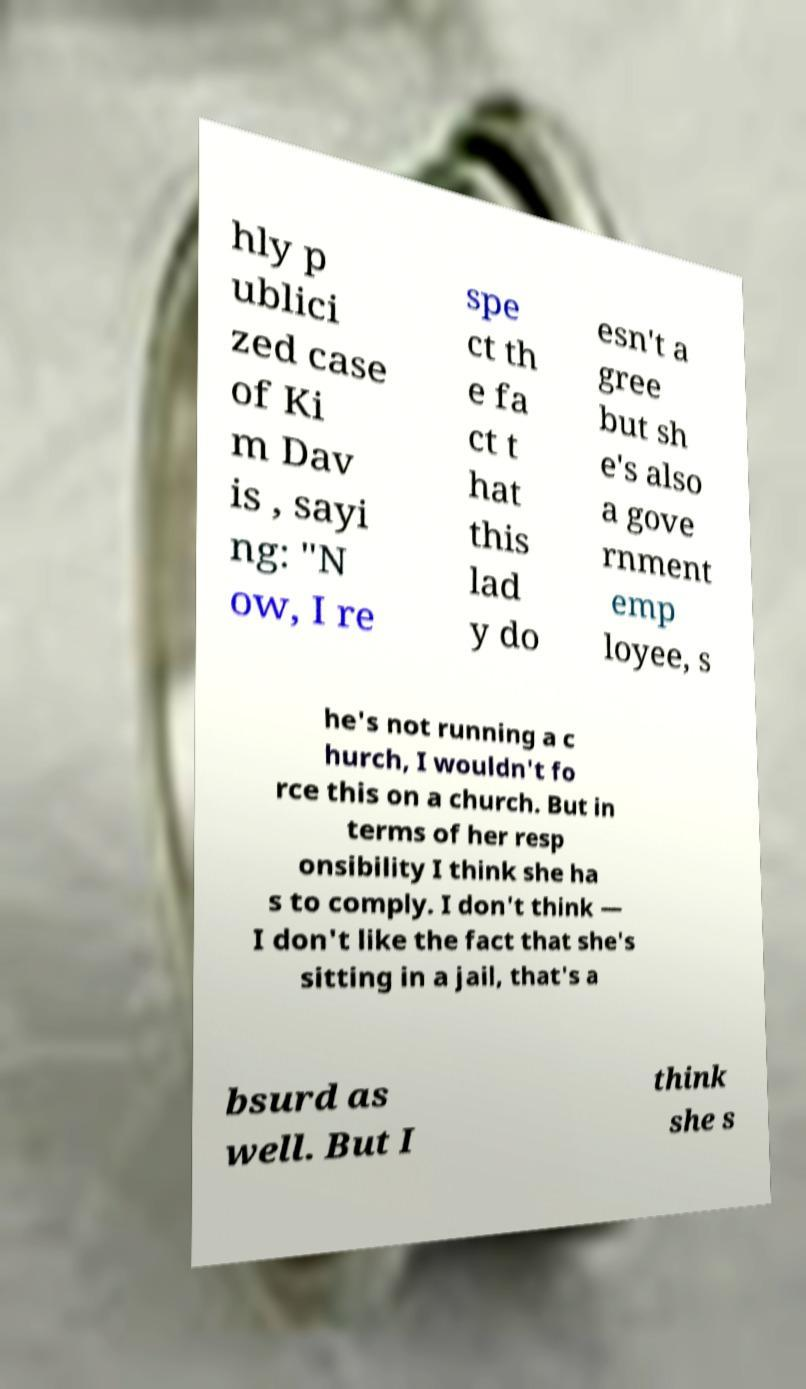Please read and relay the text visible in this image. What does it say? hly p ublici zed case of Ki m Dav is , sayi ng: "N ow, I re spe ct th e fa ct t hat this lad y do esn't a gree but sh e's also a gove rnment emp loyee, s he's not running a c hurch, I wouldn't fo rce this on a church. But in terms of her resp onsibility I think she ha s to comply. I don't think — I don't like the fact that she's sitting in a jail, that's a bsurd as well. But I think she s 